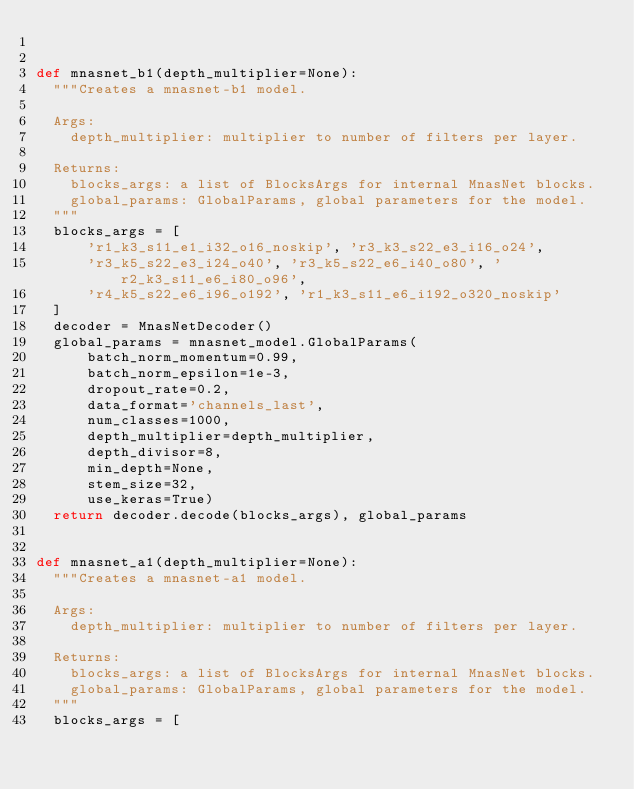Convert code to text. <code><loc_0><loc_0><loc_500><loc_500><_Python_>

def mnasnet_b1(depth_multiplier=None):
  """Creates a mnasnet-b1 model.

  Args:
    depth_multiplier: multiplier to number of filters per layer.

  Returns:
    blocks_args: a list of BlocksArgs for internal MnasNet blocks.
    global_params: GlobalParams, global parameters for the model.
  """
  blocks_args = [
      'r1_k3_s11_e1_i32_o16_noskip', 'r3_k3_s22_e3_i16_o24',
      'r3_k5_s22_e3_i24_o40', 'r3_k5_s22_e6_i40_o80', 'r2_k3_s11_e6_i80_o96',
      'r4_k5_s22_e6_i96_o192', 'r1_k3_s11_e6_i192_o320_noskip'
  ]
  decoder = MnasNetDecoder()
  global_params = mnasnet_model.GlobalParams(
      batch_norm_momentum=0.99,
      batch_norm_epsilon=1e-3,
      dropout_rate=0.2,
      data_format='channels_last',
      num_classes=1000,
      depth_multiplier=depth_multiplier,
      depth_divisor=8,
      min_depth=None,
      stem_size=32,
      use_keras=True)
  return decoder.decode(blocks_args), global_params


def mnasnet_a1(depth_multiplier=None):
  """Creates a mnasnet-a1 model.

  Args:
    depth_multiplier: multiplier to number of filters per layer.

  Returns:
    blocks_args: a list of BlocksArgs for internal MnasNet blocks.
    global_params: GlobalParams, global parameters for the model.
  """
  blocks_args = [</code> 